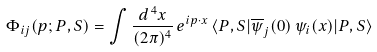Convert formula to latex. <formula><loc_0><loc_0><loc_500><loc_500>\Phi _ { i j } ( p ; P , S ) = \int \frac { d ^ { \, 4 } x } { ( 2 \pi ) ^ { 4 } } \, e ^ { i p \cdot x } \, \langle P , S | \overline { \psi } _ { j } ( 0 ) \, \psi _ { i } ( x ) | P , S \rangle</formula> 